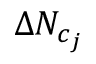<formula> <loc_0><loc_0><loc_500><loc_500>\Delta N _ { c _ { j } }</formula> 